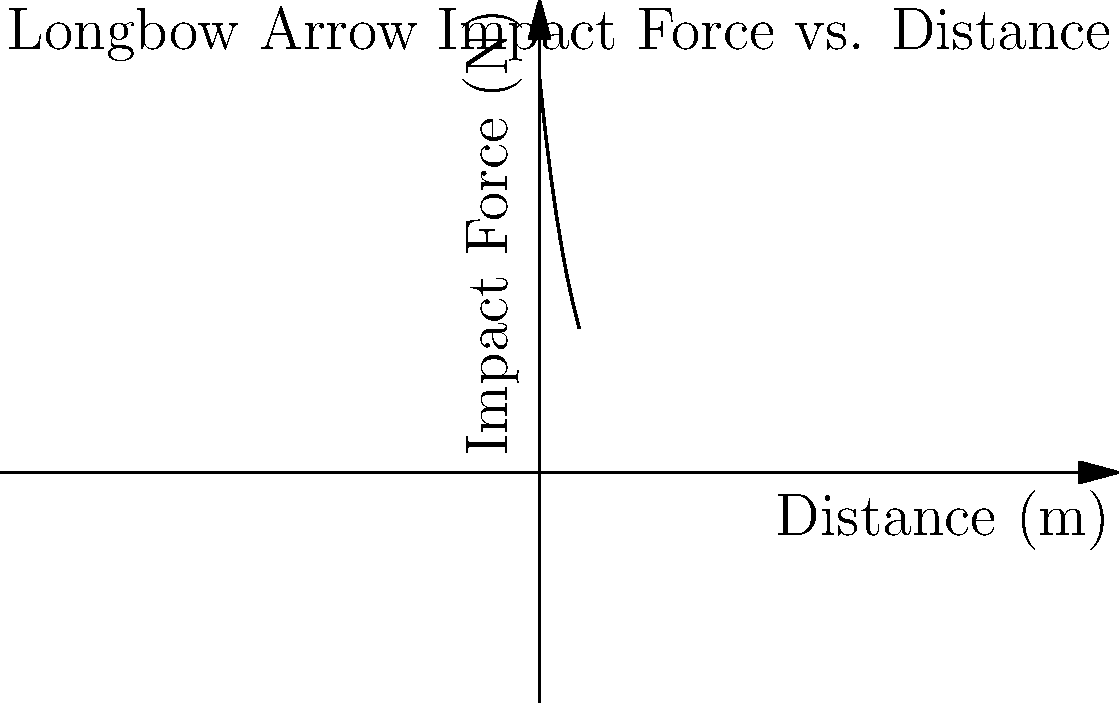A Mongolian warrior fires an arrow from a longbow with an initial impact force of 1000 N. The impact force decreases exponentially with distance according to the function $F(x) = 1000e^{-0.01x}$, where $F$ is the impact force in Newtons and $x$ is the distance in meters. At what distance will the arrow's impact force be reduced to 500 N? To solve this problem, we need to use the given exponential function and solve for $x$ when $F(x) = 500$ N.

1. Start with the equation: $F(x) = 1000e^{-0.01x}$

2. Set $F(x)$ equal to 500 N: $500 = 1000e^{-0.01x}$

3. Divide both sides by 1000: $0.5 = e^{-0.01x}$

4. Take the natural logarithm of both sides:
   $\ln(0.5) = \ln(e^{-0.01x})$

5. Simplify the right side using the properties of logarithms:
   $\ln(0.5) = -0.01x$

6. Divide both sides by -0.01:
   $\frac{\ln(0.5)}{-0.01} = x$

7. Calculate the value of $x$:
   $x \approx 69.3$ meters

Therefore, the arrow's impact force will be reduced to 500 N at a distance of approximately 69.3 meters.
Answer: 69.3 meters 